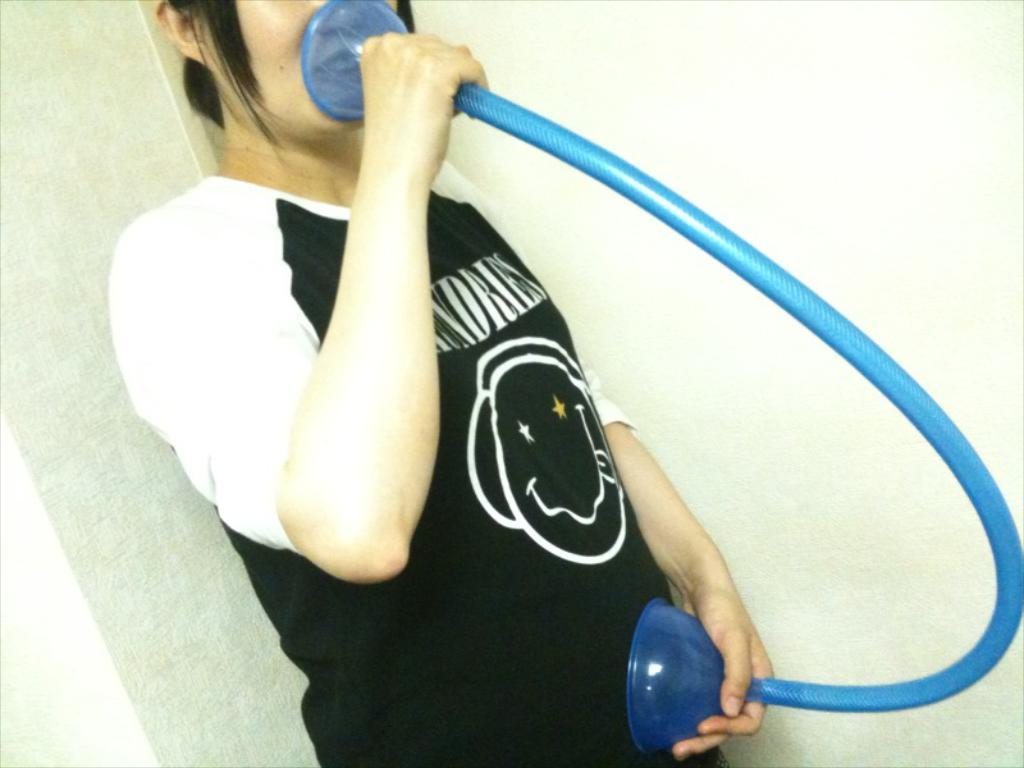What is the main subject of the image? There is a person standing in the image. What can be observed about the person's attire? The person is wearing clothes. What object is the person holding in their hands? The person is holding a pipe in their hands. What type of structure is visible in the image? There is a wall in the image. What type of furniture is visible in the image? There is no furniture present in the image. What is the plot of the story being told in the image? The image does not depict a story or plot; it is a static representation of a person standing with a pipe and a wall in the background. 